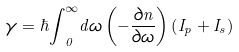Convert formula to latex. <formula><loc_0><loc_0><loc_500><loc_500>\gamma = \hbar { \int } _ { 0 } ^ { \infty } d \omega \left ( - \frac { \partial n } { \partial \omega } \right ) \left ( I _ { p } + I _ { s } \right )</formula> 